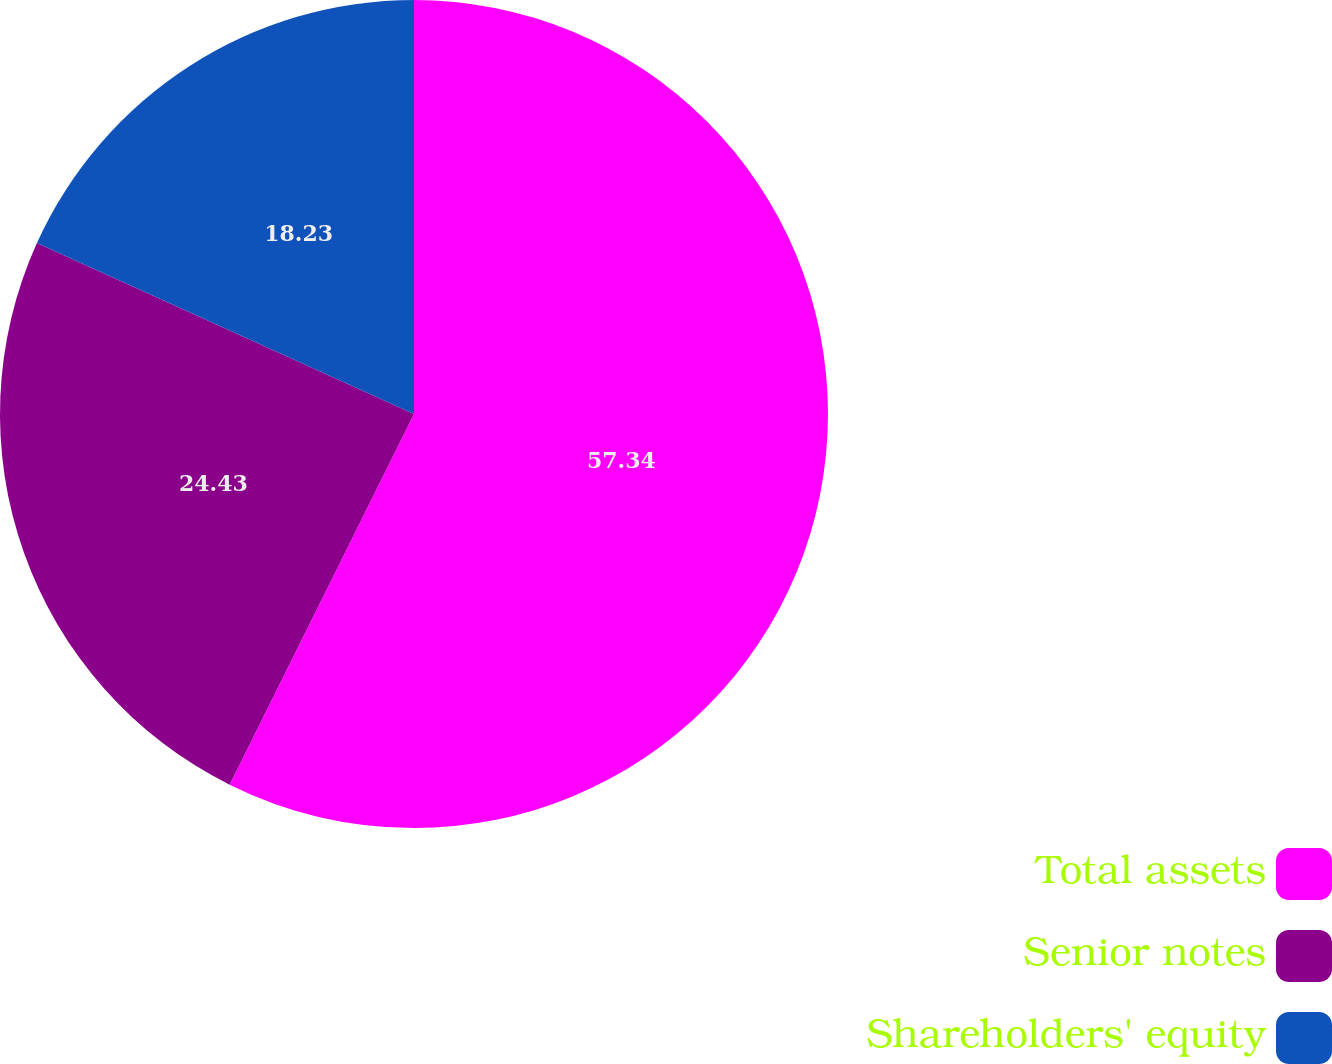Convert chart to OTSL. <chart><loc_0><loc_0><loc_500><loc_500><pie_chart><fcel>Total assets<fcel>Senior notes<fcel>Shareholders' equity<nl><fcel>57.35%<fcel>24.43%<fcel>18.23%<nl></chart> 